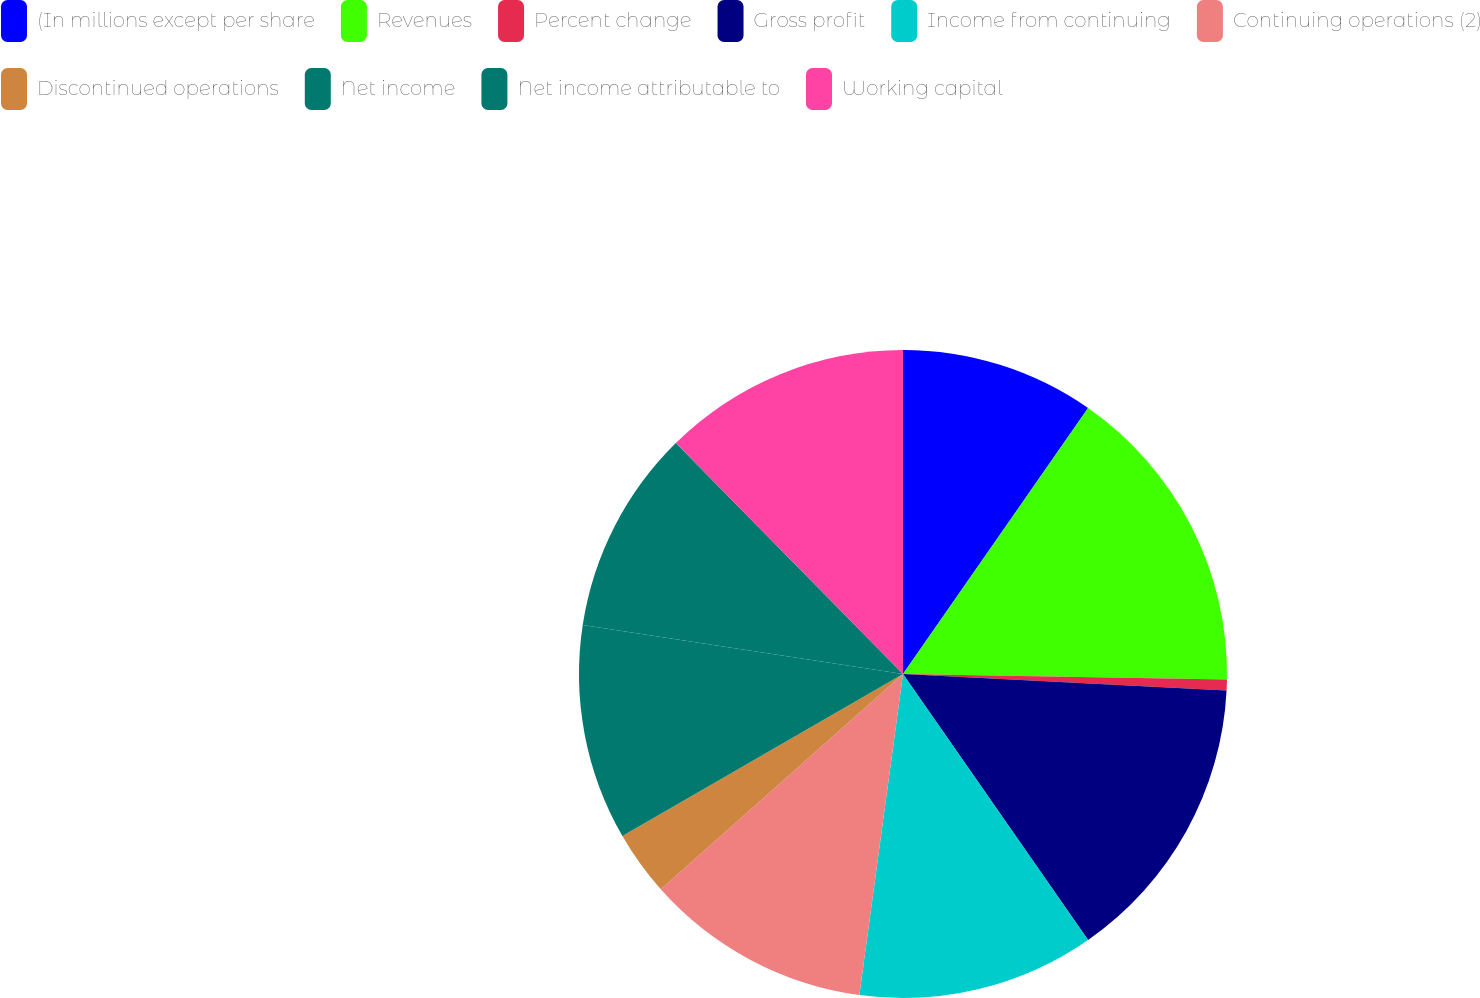Convert chart. <chart><loc_0><loc_0><loc_500><loc_500><pie_chart><fcel>(In millions except per share<fcel>Revenues<fcel>Percent change<fcel>Gross profit<fcel>Income from continuing<fcel>Continuing operations (2)<fcel>Discontinued operations<fcel>Net income<fcel>Net income attributable to<fcel>Working capital<nl><fcel>9.68%<fcel>15.59%<fcel>0.54%<fcel>14.52%<fcel>11.83%<fcel>11.29%<fcel>3.23%<fcel>10.75%<fcel>10.22%<fcel>12.37%<nl></chart> 